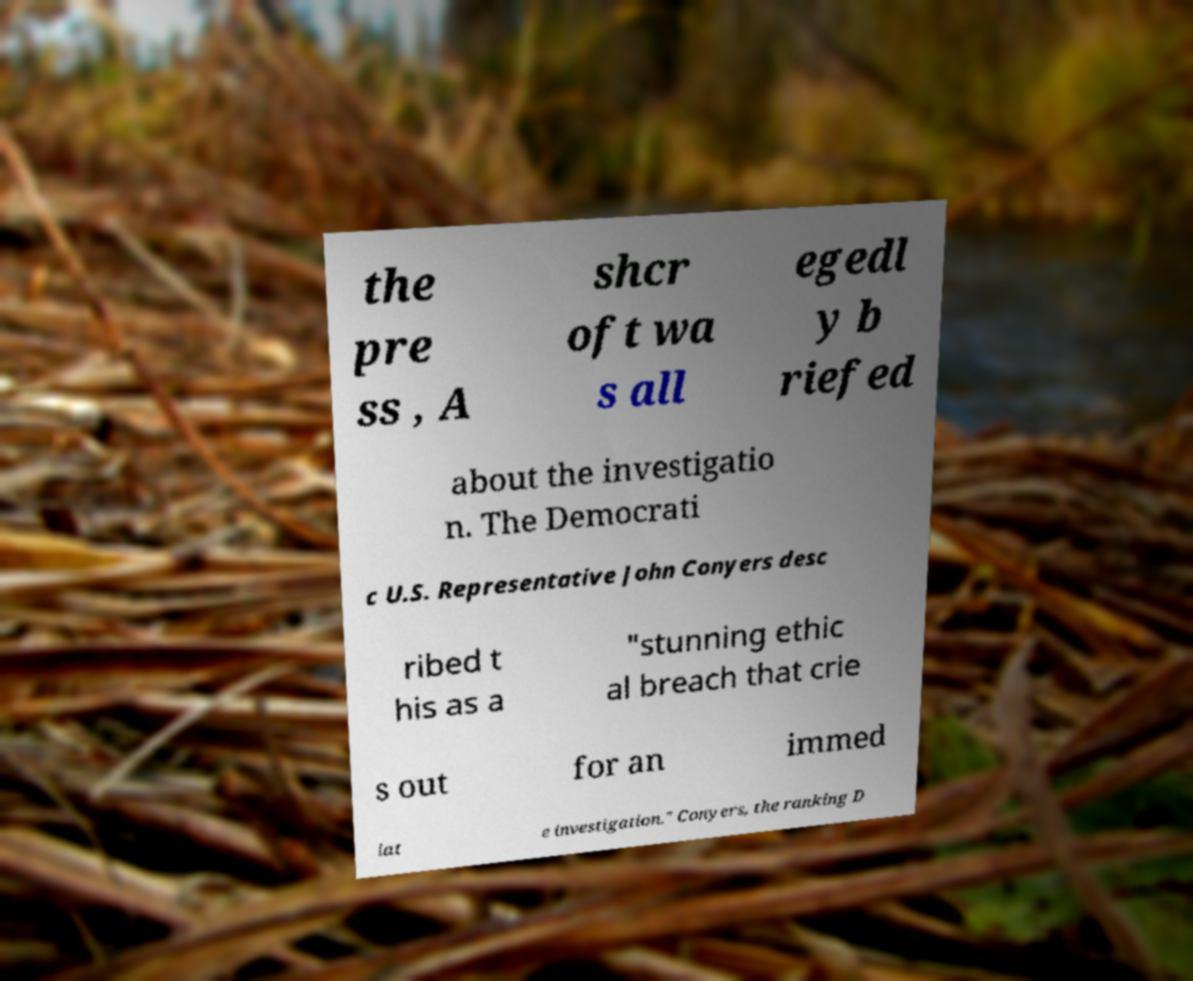Can you read and provide the text displayed in the image?This photo seems to have some interesting text. Can you extract and type it out for me? the pre ss , A shcr oft wa s all egedl y b riefed about the investigatio n. The Democrati c U.S. Representative John Conyers desc ribed t his as a "stunning ethic al breach that crie s out for an immed iat e investigation." Conyers, the ranking D 